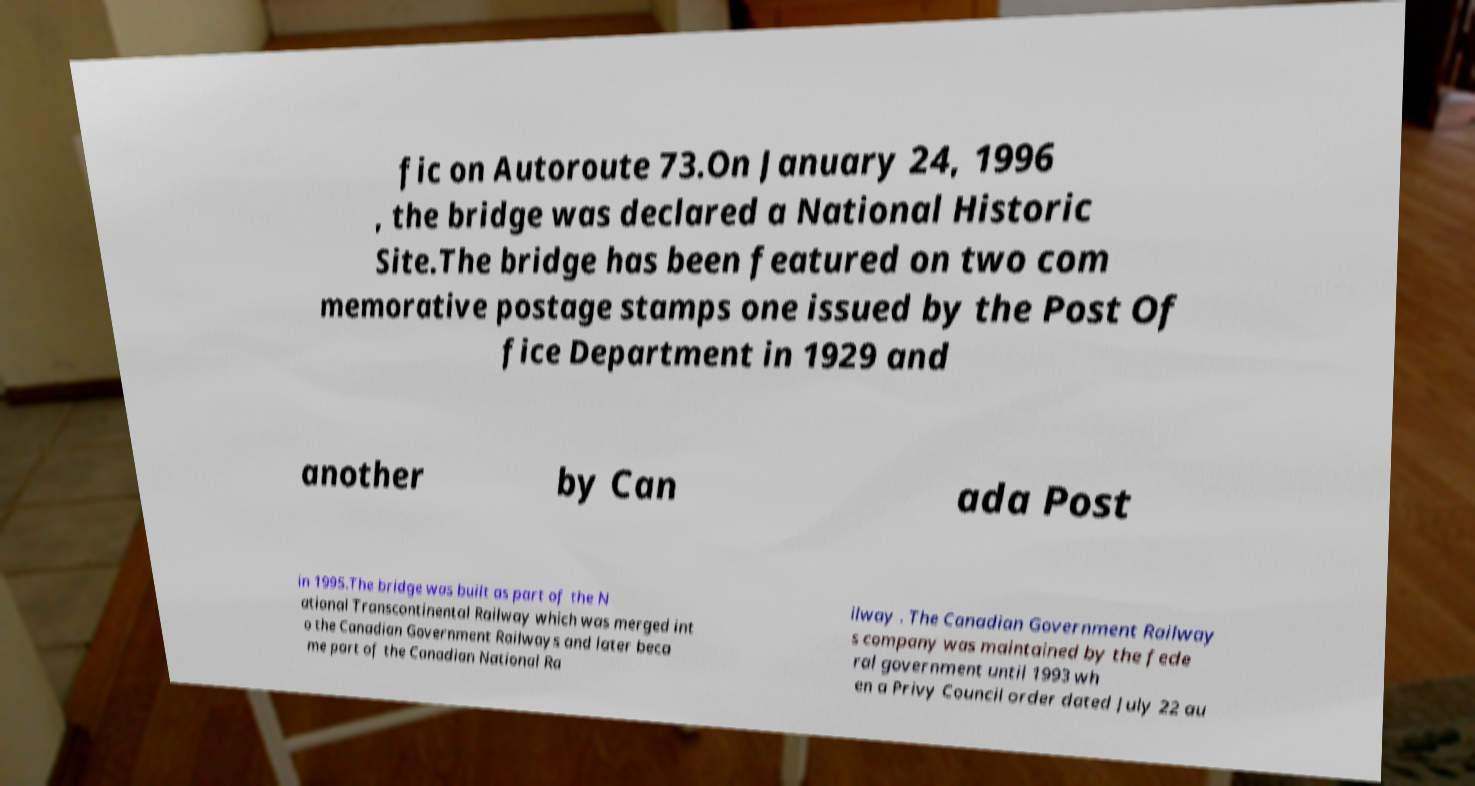Please identify and transcribe the text found in this image. fic on Autoroute 73.On January 24, 1996 , the bridge was declared a National Historic Site.The bridge has been featured on two com memorative postage stamps one issued by the Post Of fice Department in 1929 and another by Can ada Post in 1995.The bridge was built as part of the N ational Transcontinental Railway which was merged int o the Canadian Government Railways and later beca me part of the Canadian National Ra ilway . The Canadian Government Railway s company was maintained by the fede ral government until 1993 wh en a Privy Council order dated July 22 au 